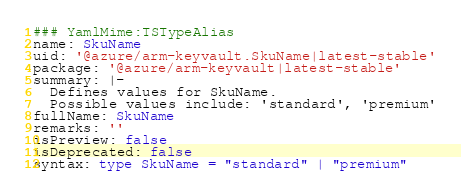<code> <loc_0><loc_0><loc_500><loc_500><_YAML_>### YamlMime:TSTypeAlias
name: SkuName
uid: '@azure/arm-keyvault.SkuName|latest-stable'
package: '@azure/arm-keyvault|latest-stable'
summary: |-
  Defines values for SkuName.
  Possible values include: 'standard', 'premium'
fullName: SkuName
remarks: ''
isPreview: false
isDeprecated: false
syntax: type SkuName = "standard" | "premium"
</code> 